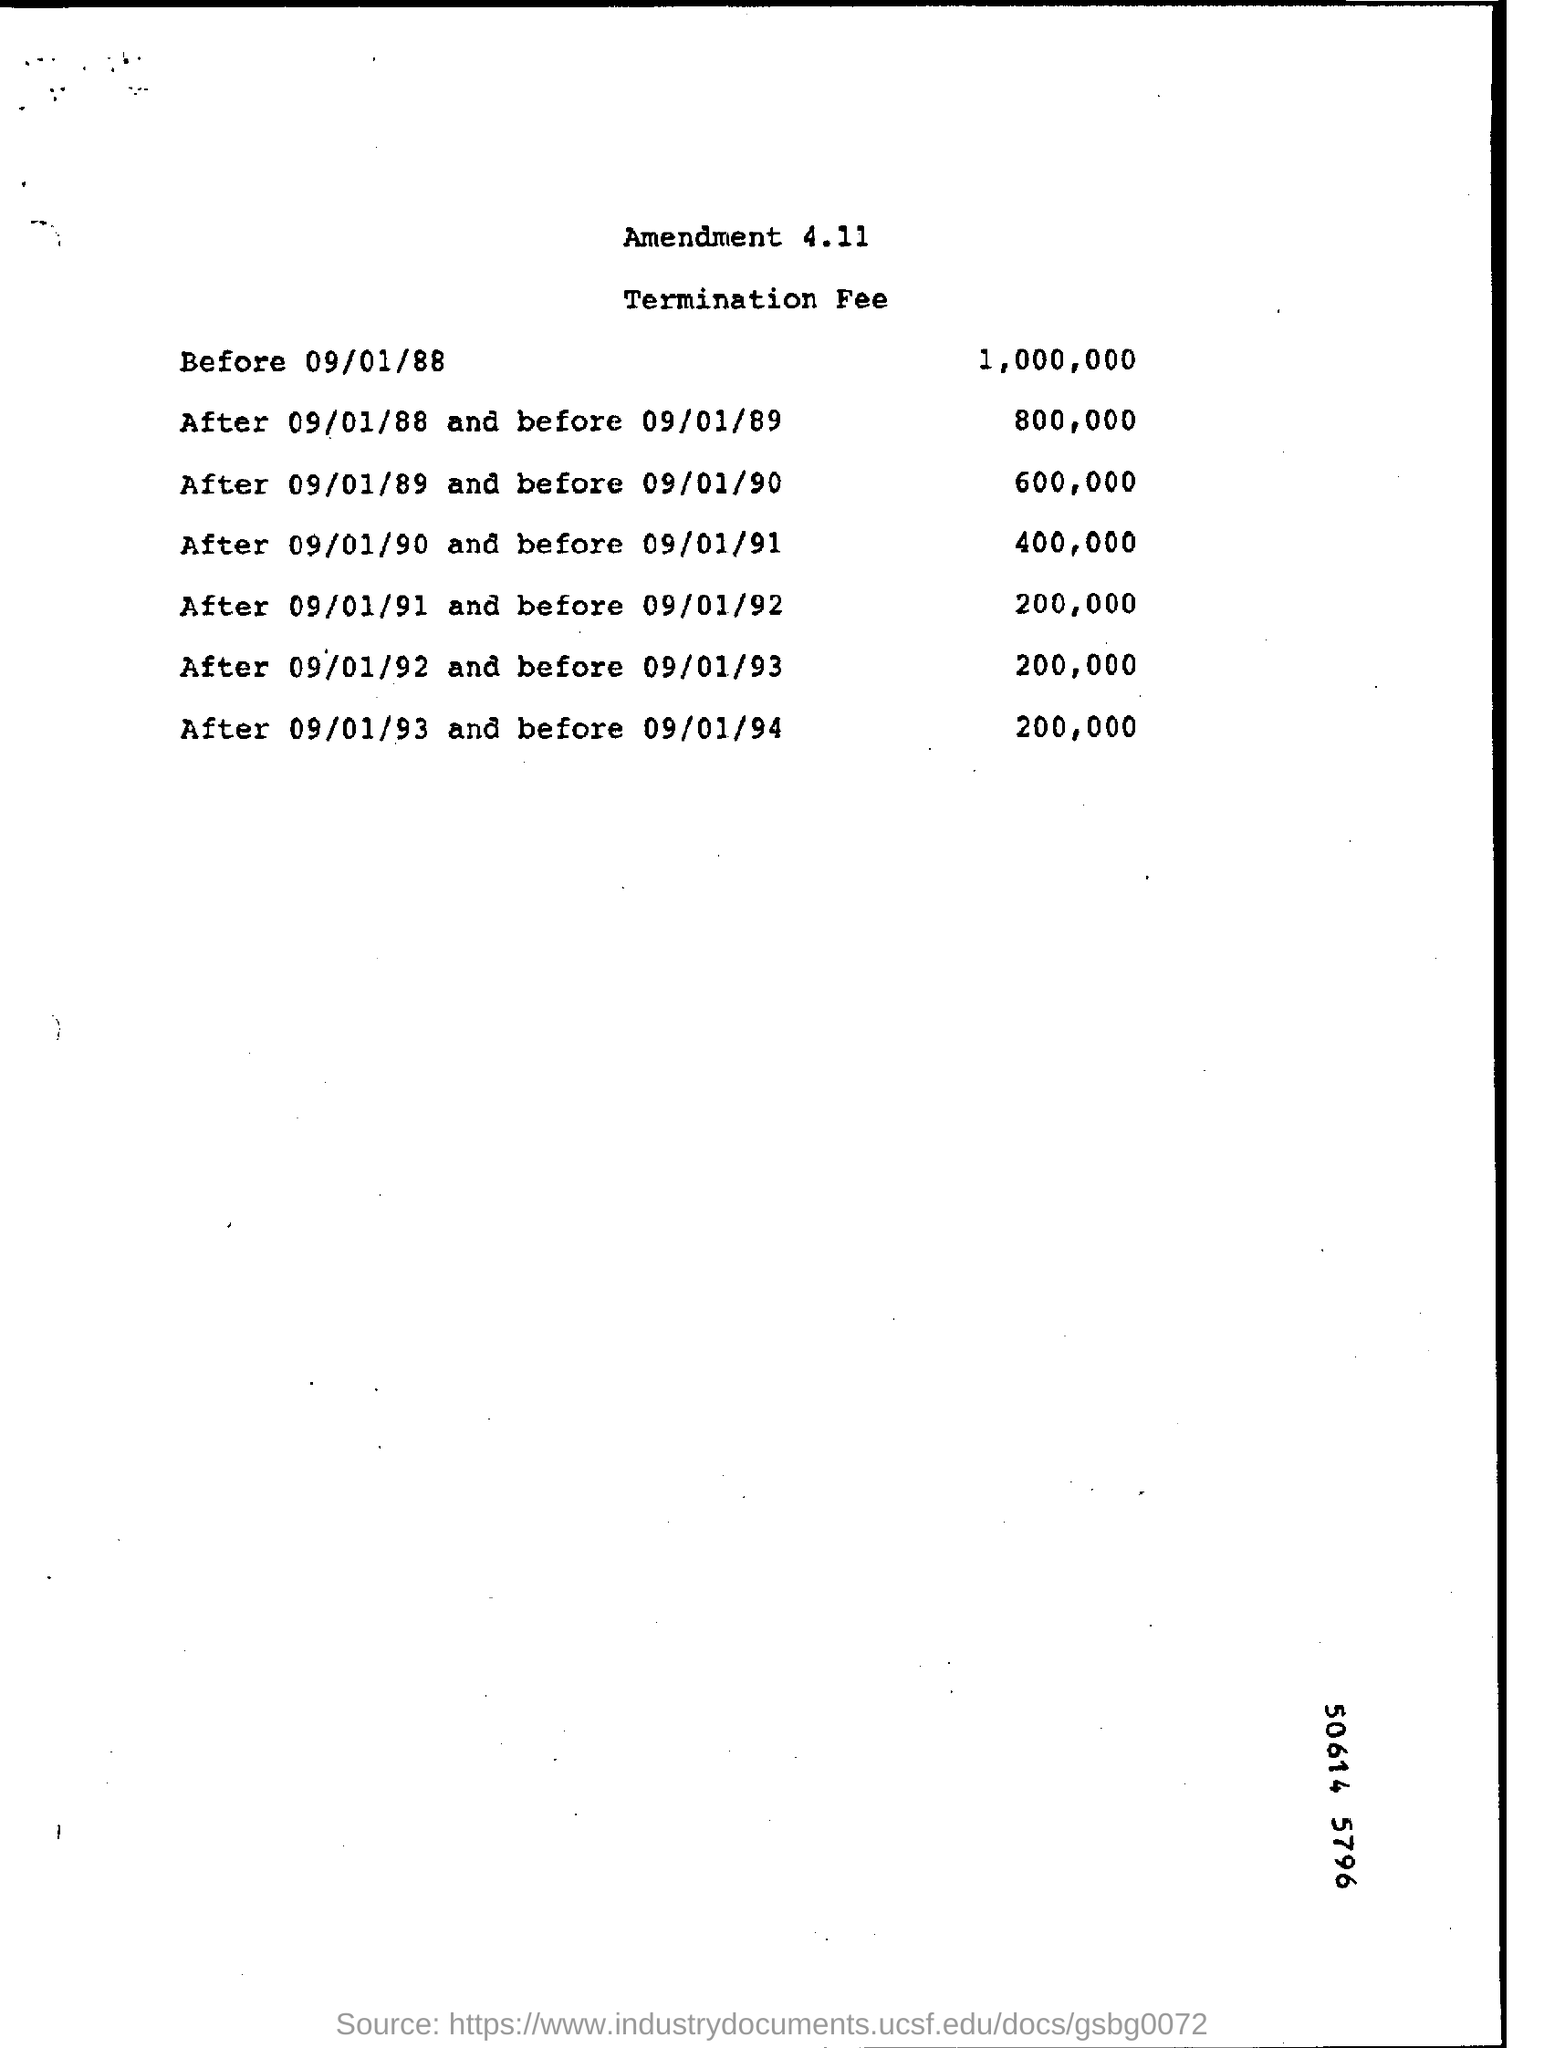Draw attention to some important aspects in this diagram. The document pertains to the subject of termination fees. The fee is 600,000 and it applies to the period of time from 09/01/89 to 09/01/90. The fee for the period between September 1, 1990 and September 1, 1991 is 400,000. The fee for the period starting on 09/01/92 and ending on 09/01/93 is 200,000. What was the fee prior to September 1, 1988? One million dollars. 